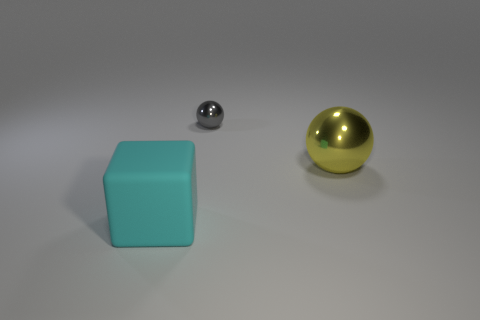What is the material of the sphere behind the big yellow ball?
Offer a terse response. Metal. There is a object that is both in front of the gray object and behind the rubber object; what is its shape?
Provide a succinct answer. Sphere. What is the small sphere made of?
Your answer should be compact. Metal. How many cylinders are big metal objects or big matte objects?
Your answer should be compact. 0. Are the small sphere and the yellow sphere made of the same material?
Keep it short and to the point. Yes. There is another object that is the same shape as the yellow object; what size is it?
Your answer should be compact. Small. The object that is both on the right side of the cyan block and in front of the tiny gray shiny object is made of what material?
Offer a very short reply. Metal. Is the number of small metallic balls right of the small object the same as the number of red matte cylinders?
Ensure brevity in your answer.  Yes. What number of things are large things left of the yellow sphere or large brown balls?
Your answer should be compact. 1. Do the big thing that is behind the large block and the tiny object have the same color?
Provide a short and direct response. No. 